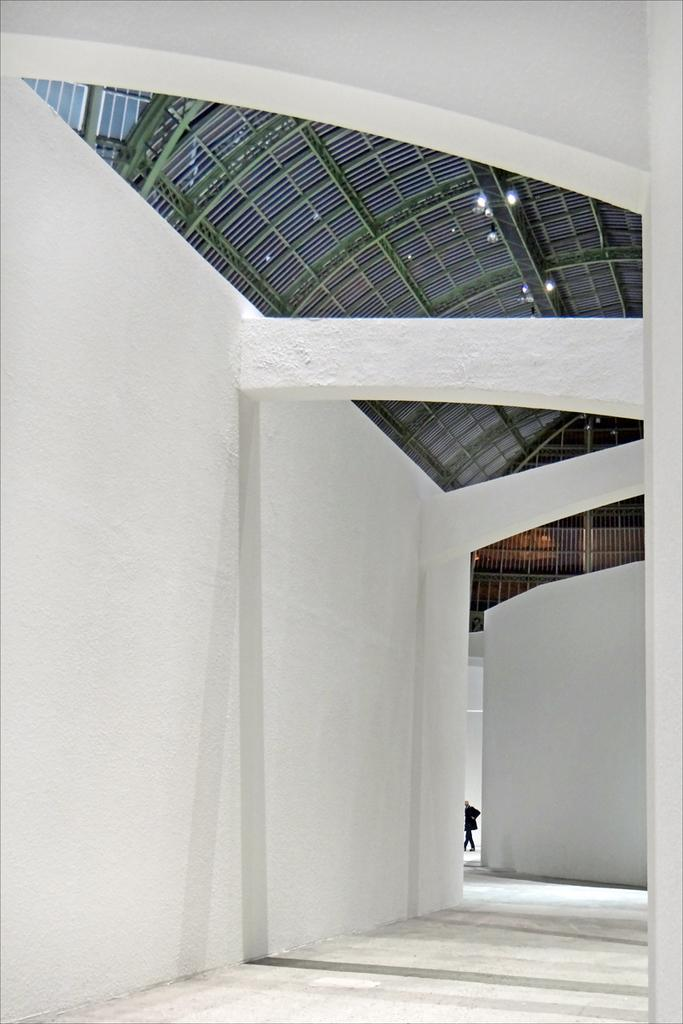What can be seen in the image that people might walk on? There is a path in the image that people might walk on. What type of structure is visible in the image? There is a white wall in the image. Can you describe the person in the image? The person is in the background of the image, but no specific details about the person are provided. How many beds are visible in the image? There are no beds present in the image. What type of division can be seen between the path and the white wall? There is no specific division mentioned between the path and the white wall in the image. 